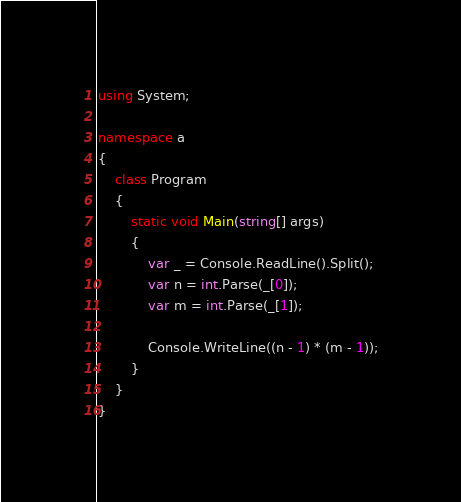Convert code to text. <code><loc_0><loc_0><loc_500><loc_500><_C#_>using System;

namespace a
{
    class Program
    {
        static void Main(string[] args)
        {
            var _ = Console.ReadLine().Split();
            var n = int.Parse(_[0]);
            var m = int.Parse(_[1]);

            Console.WriteLine((n - 1) * (m - 1));
        }
    }
}
</code> 